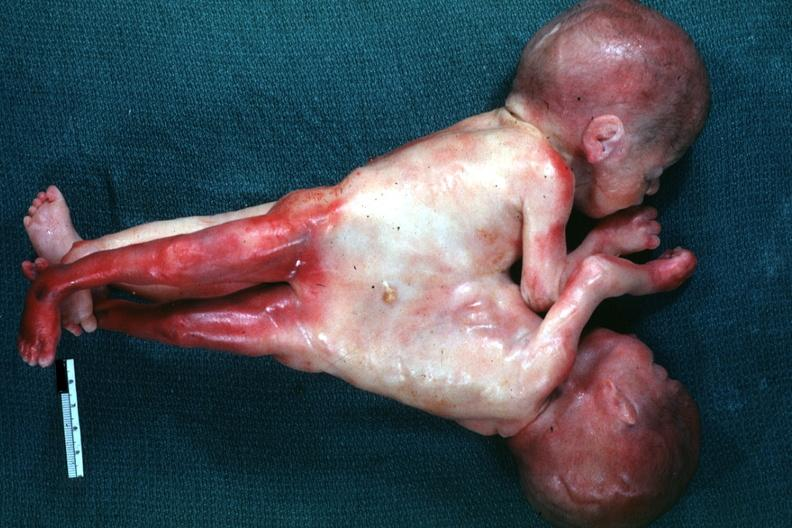what does this image show?
Answer the question using a single word or phrase. Lateral view joined at chest and abdomen 